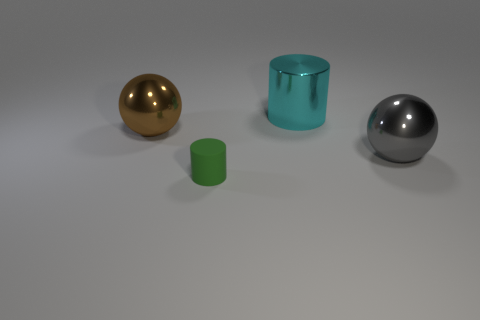Add 4 green cylinders. How many objects exist? 8 Add 2 green rubber cylinders. How many green rubber cylinders exist? 3 Subtract 1 gray spheres. How many objects are left? 3 Subtract all small green cylinders. Subtract all large gray metal balls. How many objects are left? 2 Add 3 gray metallic things. How many gray metallic things are left? 4 